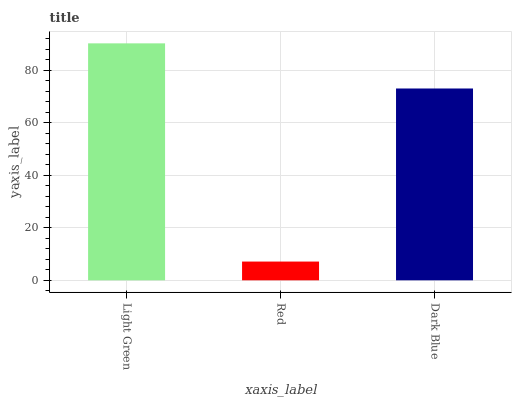Is Red the minimum?
Answer yes or no. Yes. Is Light Green the maximum?
Answer yes or no. Yes. Is Dark Blue the minimum?
Answer yes or no. No. Is Dark Blue the maximum?
Answer yes or no. No. Is Dark Blue greater than Red?
Answer yes or no. Yes. Is Red less than Dark Blue?
Answer yes or no. Yes. Is Red greater than Dark Blue?
Answer yes or no. No. Is Dark Blue less than Red?
Answer yes or no. No. Is Dark Blue the high median?
Answer yes or no. Yes. Is Dark Blue the low median?
Answer yes or no. Yes. Is Light Green the high median?
Answer yes or no. No. Is Light Green the low median?
Answer yes or no. No. 